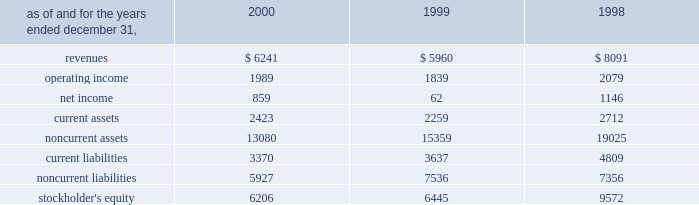A e s 2 0 0 0 f i n a n c i a l r e v i e w in may 2000 , a subsidiary of the company acquired an additional 5% ( 5 % ) of the preferred , non-voting shares of eletropaulo for approximately $ 90 million .
In january 2000 , 59% ( 59 % ) of the preferred non-voting shares were acquired for approximately $ 1 billion at auction from bndes , the national development bank of brazil .
The price established at auction was approximately $ 72.18 per 1000 shares , to be paid in four annual installments com- mencing with a payment of 18.5% ( 18.5 % ) of the total price upon closing of the transaction and installments of 25.9% ( 25.9 % ) , 27.1% ( 27.1 % ) and 28.5% ( 28.5 % ) of the total price to be paid annually thereafter .
At december 31 , 2000 , the company had a total economic interest of 49.6% ( 49.6 % ) in eletropaulo .
The company accounts for this investment using the equity method based on the related consortium agreement that allows the exercise of significant influence .
In august 2000 , a subsidiary of the company acquired a 49% ( 49 % ) interest in songas limited for approxi- mately $ 40 million .
Songas limited owns the songo songo gas-to-electricity project in tanzania .
Under the terms of a project management agreement , the company has assumed overall project management responsibility .
The project consists of the refurbishment and operation of five natural gas wells in coastal tanzania , the construction and operation of a 65 mmscf/day gas processing plant and related facilities , the construction of a 230 km marine and land pipeline from the gas plant to dar es salaam and the conversion and upgrading of an existing 112 mw power station in dar es salaam to burn natural gas , with an optional additional unit to be constructed at the plant .
Since the project is currently under construction , no rev- enues or expenses have been incurred , and therefore no results are shown in the table .
In december 2000 , a subsidiary of the company with edf international s.a .
( 201cedf 201d ) completed the acquisition of an additional 3.5% ( 3.5 % ) interest in light from two sub- sidiaries of reliant energy for approximately $ 136 mil- lion .
Pursuant to the acquisition , the company acquired 30% ( 30 % ) of the shares while edf acquired the remainder .
With the completion of this transaction , the company owns approximately 21.14% ( 21.14 % ) of light .
In december 2000 , a subsidiary of the company entered into an agreement with edf to jointly acquire an additional 9.2% ( 9.2 % ) interest in light , which is held by a sub- sidiary of companhia siderurgica nacional ( 201ccsn 201d ) .
Pursuant to this transaction , the company acquired an additional 2.75% ( 2.75 % ) interest in light for $ 114.6 million .
This transaction closed in january 2001 .
Following the purchase of the light shares previously owned by csn , aes and edf will together be the con- trolling shareholders of light and eletropaulo .
Aes and edf have agreed that aes will eventually take operational control of eletropaulo and the telecom businesses of light and eletropaulo , while edf will eventually take opera- tional control of light and eletropaulo 2019s electric workshop business .
Aes and edf intend to continue to pursue a fur- ther rationalization of their ownership stakes in light and eletropaulo , the result of which aes would become the sole controlling shareholder of eletropaulo and edf would become the sole controlling shareholder of light .
Upon consummation of the transaction , aes will begin consolidating eletropaulo 2019s operating results .
The struc- ture and process by which this rationalization may be effected , and the resulting timing , have yet to be deter- mined and will likely be subject to approval by various brazilian regulatory authorities and other third parties .
As a result , there can be no assurance that this rationalization will take place .
In may 1999 , a subsidiary of the company acquired subscription rights from the brazilian state-controlled eletrobras which allowed it to purchase preferred , non- voting shares in eletropaulo and common shares in light .
The aggregate purchase price of the subscription rights and the underlying shares in light and eletropaulo was approximately $ 53 million and $ 77 million , respectively , and represented 3.7% ( 3.7 % ) and 4.4% ( 4.4 % ) economic ownership interest in their capital stock , respectively .
The table presents summarized financial information ( in millions ) for the company 2019s investments in 50% ( 50 % ) or less owned investments accounted for using the equity method: .

What was the implied value of the preferred shares of eletropaulo based on the bndes acquisition , in billions? 
Computations: (1 / 59%)
Answer: 1.69492. 